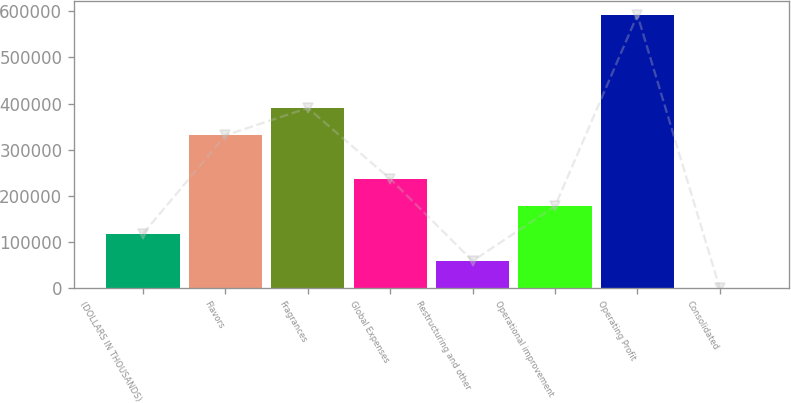Convert chart. <chart><loc_0><loc_0><loc_500><loc_500><bar_chart><fcel>(DOLLARS IN THOUSANDS)<fcel>Flavors<fcel>Fragrances<fcel>Global Expenses<fcel>Restructuring and other<fcel>Operational improvement<fcel>Operating Profit<fcel>Consolidated<nl><fcel>118480<fcel>331257<fcel>390487<fcel>236940<fcel>59249.4<fcel>177710<fcel>592321<fcel>19.2<nl></chart> 